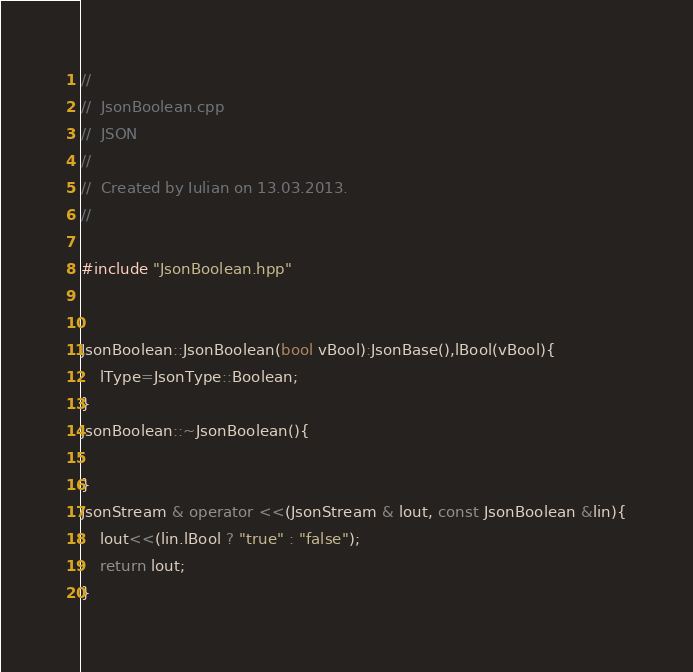Convert code to text. <code><loc_0><loc_0><loc_500><loc_500><_C++_>//
//  JsonBoolean.cpp
//  JSON
//
//  Created by Iulian on 13.03.2013.
//

#include "JsonBoolean.hpp"

 
JsonBoolean::JsonBoolean(bool vBool):JsonBase(),lBool(vBool){
    lType=JsonType::Boolean;
}
JsonBoolean::~JsonBoolean(){
    
}
JsonStream & operator <<(JsonStream & lout, const JsonBoolean &lin){
    lout<<(lin.lBool ? "true" : "false");
    return lout;
}
</code> 